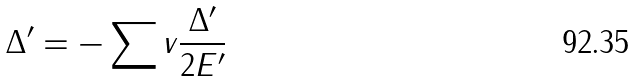<formula> <loc_0><loc_0><loc_500><loc_500>\Delta ^ { \prime } = - \sum v \frac { \Delta ^ { \prime } } { 2 E ^ { \prime } }</formula> 